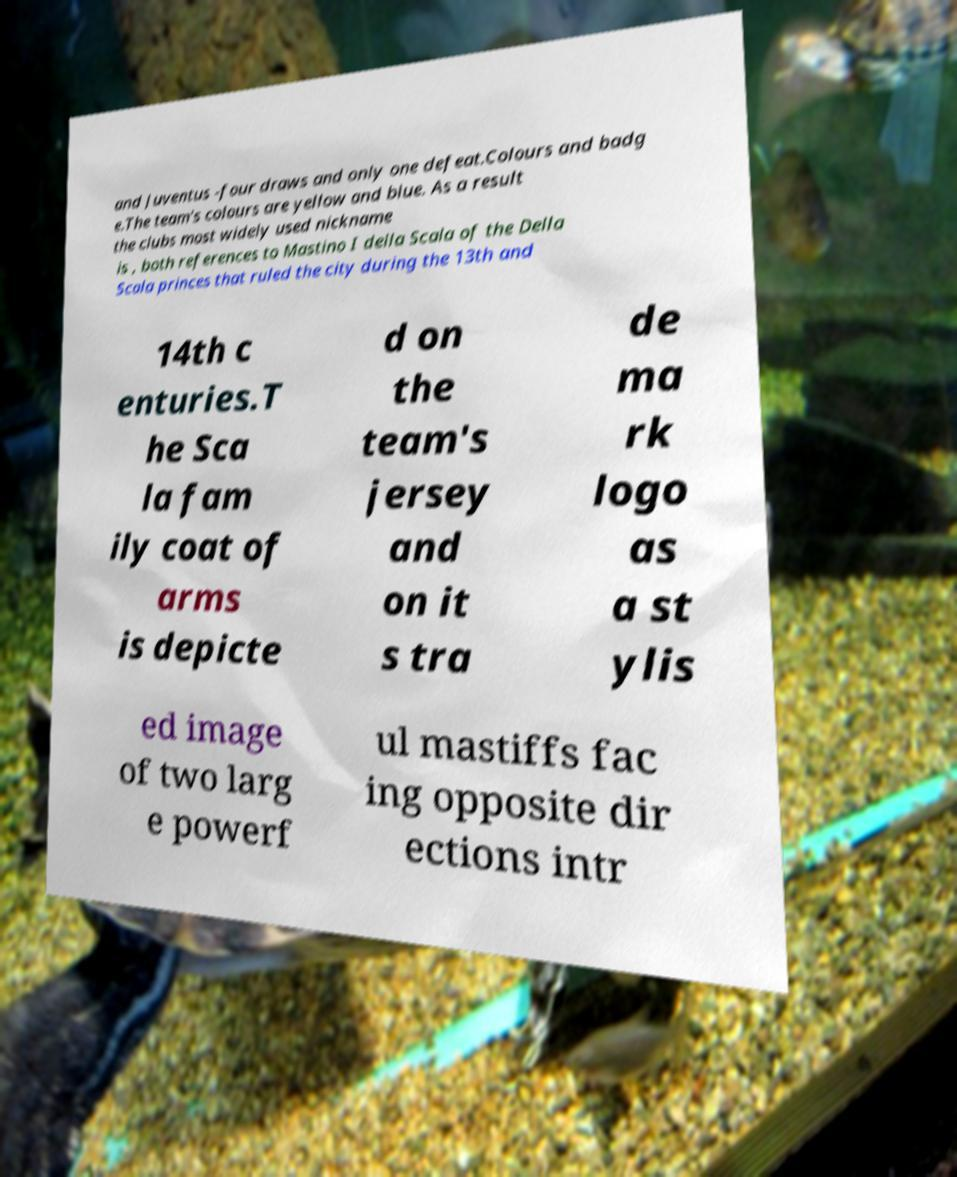I need the written content from this picture converted into text. Can you do that? and Juventus -four draws and only one defeat.Colours and badg e.The team's colours are yellow and blue. As a result the clubs most widely used nickname is , both references to Mastino I della Scala of the Della Scala princes that ruled the city during the 13th and 14th c enturies.T he Sca la fam ily coat of arms is depicte d on the team's jersey and on it s tra de ma rk logo as a st ylis ed image of two larg e powerf ul mastiffs fac ing opposite dir ections intr 